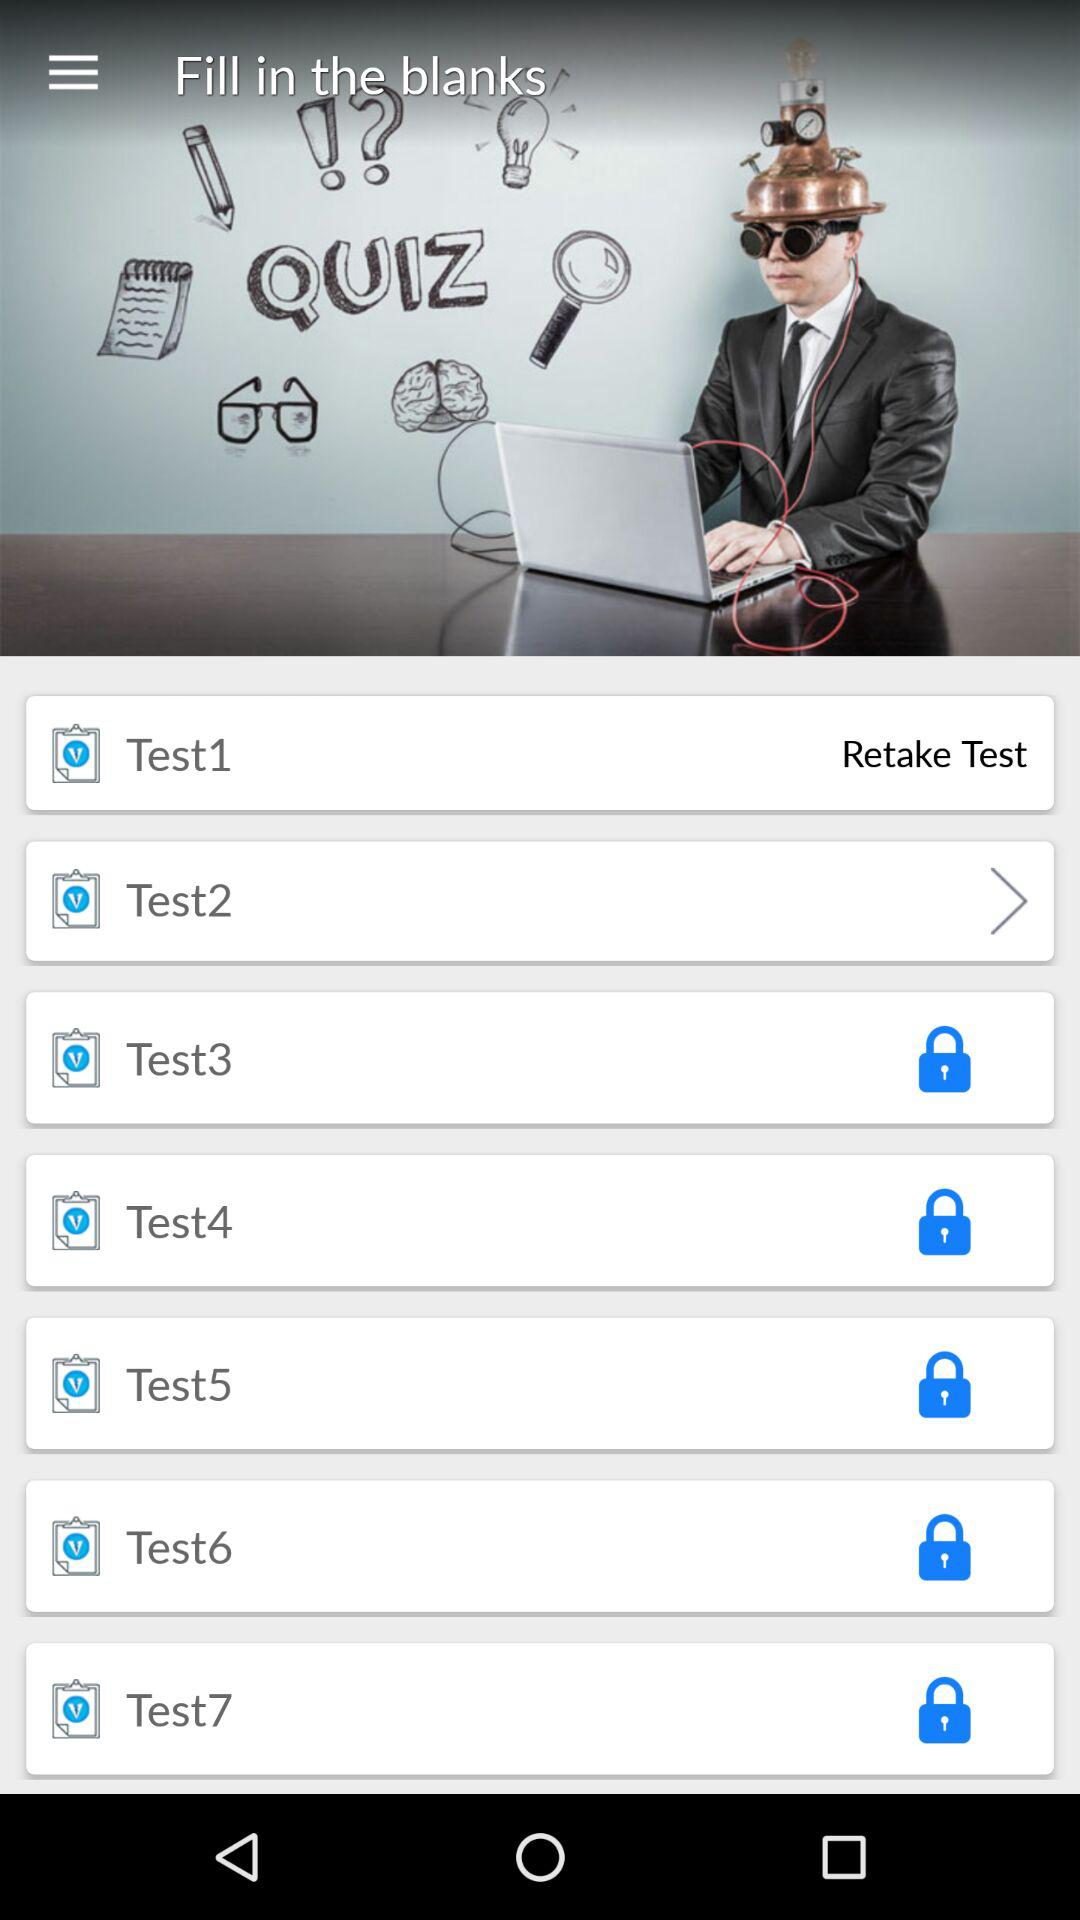Which test is completed? The completed test is "Test1". 